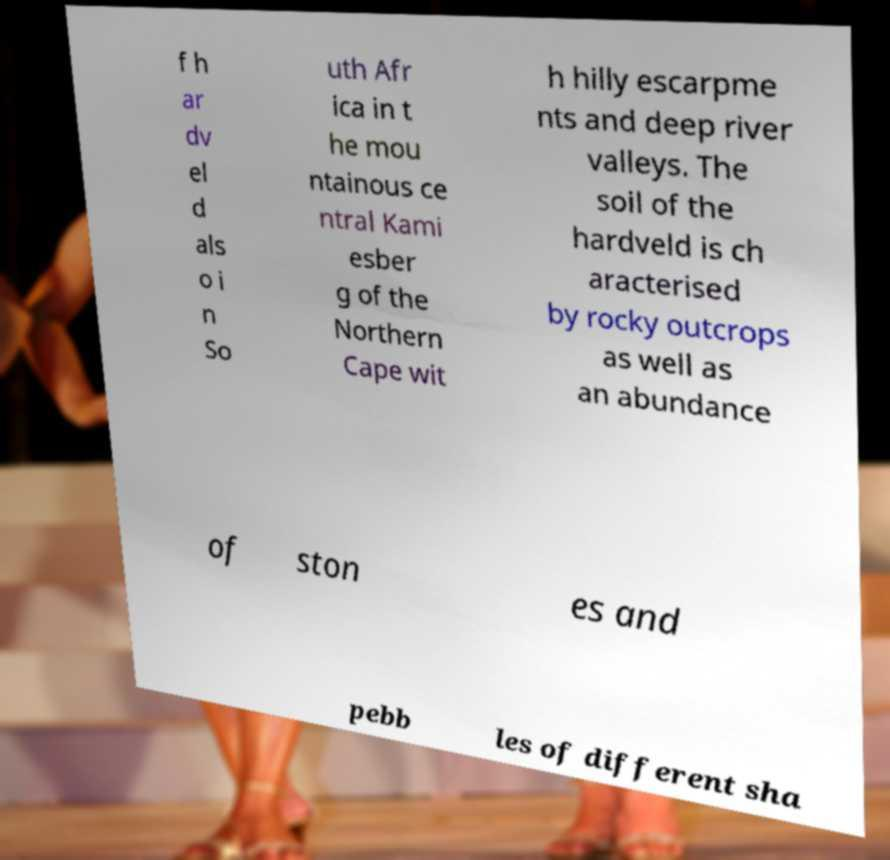For documentation purposes, I need the text within this image transcribed. Could you provide that? f h ar dv el d als o i n So uth Afr ica in t he mou ntainous ce ntral Kami esber g of the Northern Cape wit h hilly escarpme nts and deep river valleys. The soil of the hardveld is ch aracterised by rocky outcrops as well as an abundance of ston es and pebb les of different sha 